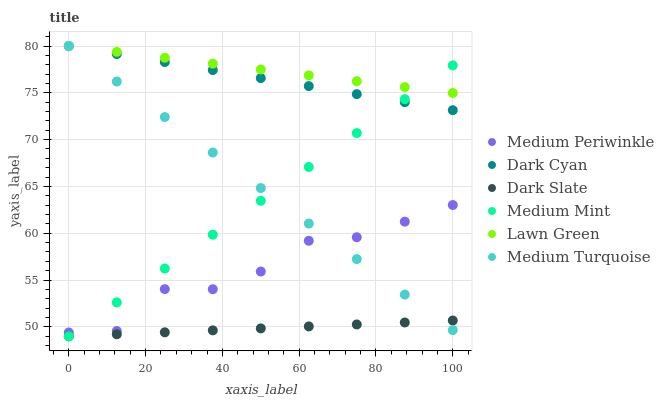Does Dark Slate have the minimum area under the curve?
Answer yes or no. Yes. Does Lawn Green have the maximum area under the curve?
Answer yes or no. Yes. Does Medium Periwinkle have the minimum area under the curve?
Answer yes or no. No. Does Medium Periwinkle have the maximum area under the curve?
Answer yes or no. No. Is Dark Slate the smoothest?
Answer yes or no. Yes. Is Medium Periwinkle the roughest?
Answer yes or no. Yes. Is Lawn Green the smoothest?
Answer yes or no. No. Is Lawn Green the roughest?
Answer yes or no. No. Does Medium Mint have the lowest value?
Answer yes or no. Yes. Does Medium Periwinkle have the lowest value?
Answer yes or no. No. Does Dark Cyan have the highest value?
Answer yes or no. Yes. Does Medium Periwinkle have the highest value?
Answer yes or no. No. Is Medium Periwinkle less than Lawn Green?
Answer yes or no. Yes. Is Dark Cyan greater than Dark Slate?
Answer yes or no. Yes. Does Medium Mint intersect Medium Turquoise?
Answer yes or no. Yes. Is Medium Mint less than Medium Turquoise?
Answer yes or no. No. Is Medium Mint greater than Medium Turquoise?
Answer yes or no. No. Does Medium Periwinkle intersect Lawn Green?
Answer yes or no. No. 